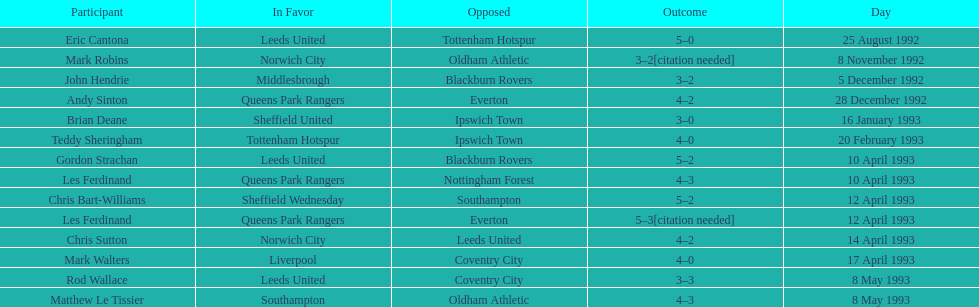Parse the full table. {'header': ['Participant', 'In Favor', 'Opposed', 'Outcome', 'Day'], 'rows': [['Eric Cantona', 'Leeds United', 'Tottenham Hotspur', '5–0', '25 August 1992'], ['Mark Robins', 'Norwich City', 'Oldham Athletic', '3–2[citation needed]', '8 November 1992'], ['John Hendrie', 'Middlesbrough', 'Blackburn Rovers', '3–2', '5 December 1992'], ['Andy Sinton', 'Queens Park Rangers', 'Everton', '4–2', '28 December 1992'], ['Brian Deane', 'Sheffield United', 'Ipswich Town', '3–0', '16 January 1993'], ['Teddy Sheringham', 'Tottenham Hotspur', 'Ipswich Town', '4–0', '20 February 1993'], ['Gordon Strachan', 'Leeds United', 'Blackburn Rovers', '5–2', '10 April 1993'], ['Les Ferdinand', 'Queens Park Rangers', 'Nottingham Forest', '4–3', '10 April 1993'], ['Chris Bart-Williams', 'Sheffield Wednesday', 'Southampton', '5–2', '12 April 1993'], ['Les Ferdinand', 'Queens Park Rangers', 'Everton', '5–3[citation needed]', '12 April 1993'], ['Chris Sutton', 'Norwich City', 'Leeds United', '4–2', '14 April 1993'], ['Mark Walters', 'Liverpool', 'Coventry City', '4–0', '17 April 1993'], ['Rod Wallace', 'Leeds United', 'Coventry City', '3–3', '8 May 1993'], ['Matthew Le Tissier', 'Southampton', 'Oldham Athletic', '4–3', '8 May 1993']]} Who are all the players? Eric Cantona, Mark Robins, John Hendrie, Andy Sinton, Brian Deane, Teddy Sheringham, Gordon Strachan, Les Ferdinand, Chris Bart-Williams, Les Ferdinand, Chris Sutton, Mark Walters, Rod Wallace, Matthew Le Tissier. What were their results? 5–0, 3–2[citation needed], 3–2, 4–2, 3–0, 4–0, 5–2, 4–3, 5–2, 5–3[citation needed], 4–2, 4–0, 3–3, 4–3. Which player tied with mark robins? John Hendrie. 